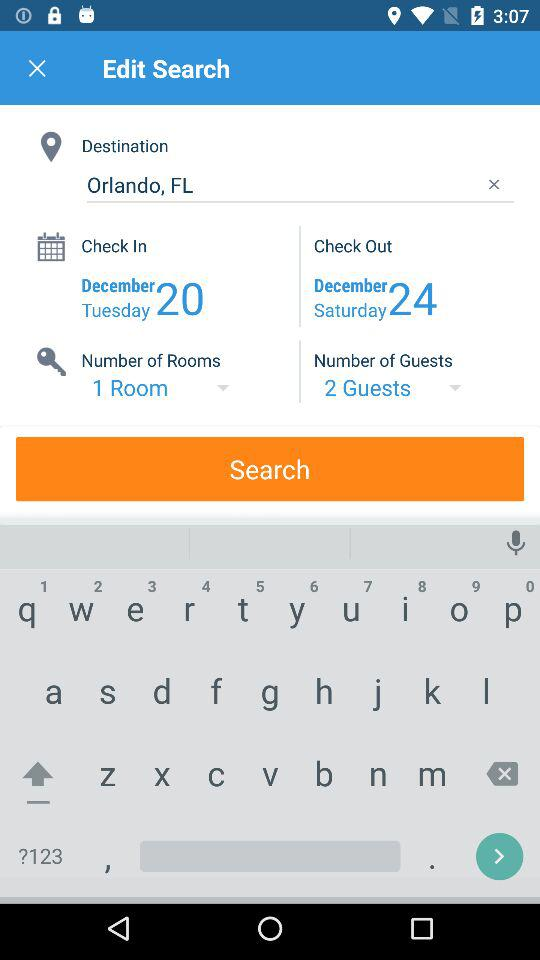What is the destination? The destination is Orlando, FL. 